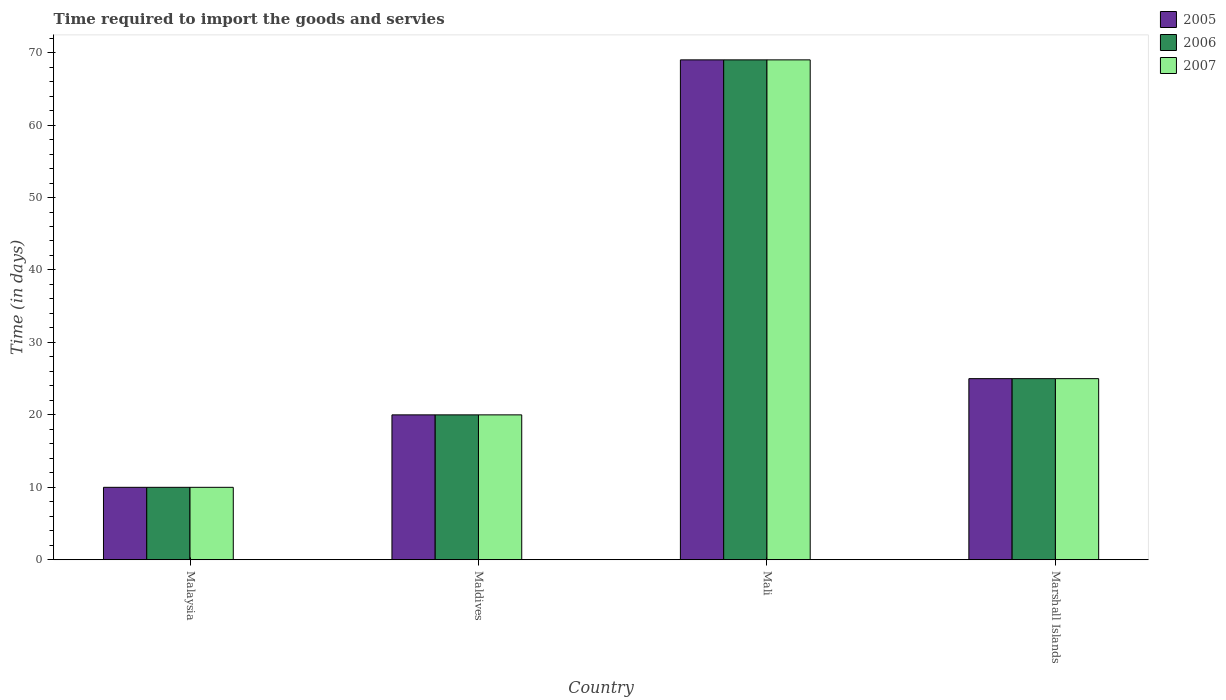How many different coloured bars are there?
Your answer should be very brief. 3. Are the number of bars on each tick of the X-axis equal?
Make the answer very short. Yes. How many bars are there on the 2nd tick from the right?
Keep it short and to the point. 3. What is the label of the 3rd group of bars from the left?
Your answer should be very brief. Mali. In how many cases, is the number of bars for a given country not equal to the number of legend labels?
Your answer should be very brief. 0. What is the number of days required to import the goods and services in 2005 in Malaysia?
Your response must be concise. 10. Across all countries, what is the maximum number of days required to import the goods and services in 2007?
Ensure brevity in your answer.  69. In which country was the number of days required to import the goods and services in 2006 maximum?
Make the answer very short. Mali. In which country was the number of days required to import the goods and services in 2006 minimum?
Provide a short and direct response. Malaysia. What is the total number of days required to import the goods and services in 2006 in the graph?
Provide a short and direct response. 124. What is the difference between the number of days required to import the goods and services in 2005 in Maldives and that in Mali?
Your response must be concise. -49. What is the difference between the number of days required to import the goods and services in 2007 in Mali and the number of days required to import the goods and services in 2006 in Maldives?
Offer a terse response. 49. What is the average number of days required to import the goods and services in 2007 per country?
Offer a terse response. 31. Is the sum of the number of days required to import the goods and services in 2005 in Malaysia and Maldives greater than the maximum number of days required to import the goods and services in 2007 across all countries?
Provide a succinct answer. No. What does the 3rd bar from the right in Malaysia represents?
Offer a terse response. 2005. Is it the case that in every country, the sum of the number of days required to import the goods and services in 2005 and number of days required to import the goods and services in 2007 is greater than the number of days required to import the goods and services in 2006?
Keep it short and to the point. Yes. Are all the bars in the graph horizontal?
Ensure brevity in your answer.  No. Does the graph contain grids?
Provide a succinct answer. No. How are the legend labels stacked?
Your answer should be very brief. Vertical. What is the title of the graph?
Provide a short and direct response. Time required to import the goods and servies. What is the label or title of the Y-axis?
Make the answer very short. Time (in days). What is the Time (in days) of 2005 in Maldives?
Keep it short and to the point. 20. What is the Time (in days) in 2006 in Maldives?
Your response must be concise. 20. What is the Time (in days) in 2007 in Maldives?
Your answer should be very brief. 20. What is the Time (in days) of 2007 in Mali?
Provide a succinct answer. 69. What is the Time (in days) of 2006 in Marshall Islands?
Provide a short and direct response. 25. What is the Time (in days) of 2007 in Marshall Islands?
Provide a succinct answer. 25. Across all countries, what is the maximum Time (in days) of 2007?
Your answer should be compact. 69. Across all countries, what is the minimum Time (in days) of 2005?
Provide a short and direct response. 10. Across all countries, what is the minimum Time (in days) of 2006?
Offer a terse response. 10. Across all countries, what is the minimum Time (in days) in 2007?
Your answer should be compact. 10. What is the total Time (in days) of 2005 in the graph?
Provide a short and direct response. 124. What is the total Time (in days) in 2006 in the graph?
Keep it short and to the point. 124. What is the total Time (in days) of 2007 in the graph?
Provide a short and direct response. 124. What is the difference between the Time (in days) in 2005 in Malaysia and that in Mali?
Your response must be concise. -59. What is the difference between the Time (in days) of 2006 in Malaysia and that in Mali?
Give a very brief answer. -59. What is the difference between the Time (in days) in 2007 in Malaysia and that in Mali?
Give a very brief answer. -59. What is the difference between the Time (in days) of 2006 in Malaysia and that in Marshall Islands?
Offer a very short reply. -15. What is the difference between the Time (in days) in 2005 in Maldives and that in Mali?
Your answer should be very brief. -49. What is the difference between the Time (in days) in 2006 in Maldives and that in Mali?
Ensure brevity in your answer.  -49. What is the difference between the Time (in days) in 2007 in Maldives and that in Mali?
Provide a succinct answer. -49. What is the difference between the Time (in days) in 2005 in Maldives and that in Marshall Islands?
Offer a very short reply. -5. What is the difference between the Time (in days) in 2006 in Maldives and that in Marshall Islands?
Offer a terse response. -5. What is the difference between the Time (in days) in 2007 in Mali and that in Marshall Islands?
Give a very brief answer. 44. What is the difference between the Time (in days) in 2005 in Malaysia and the Time (in days) in 2006 in Maldives?
Provide a succinct answer. -10. What is the difference between the Time (in days) in 2005 in Malaysia and the Time (in days) in 2007 in Maldives?
Offer a terse response. -10. What is the difference between the Time (in days) in 2005 in Malaysia and the Time (in days) in 2006 in Mali?
Offer a very short reply. -59. What is the difference between the Time (in days) of 2005 in Malaysia and the Time (in days) of 2007 in Mali?
Ensure brevity in your answer.  -59. What is the difference between the Time (in days) in 2006 in Malaysia and the Time (in days) in 2007 in Mali?
Keep it short and to the point. -59. What is the difference between the Time (in days) in 2005 in Malaysia and the Time (in days) in 2007 in Marshall Islands?
Provide a short and direct response. -15. What is the difference between the Time (in days) of 2006 in Malaysia and the Time (in days) of 2007 in Marshall Islands?
Your answer should be compact. -15. What is the difference between the Time (in days) in 2005 in Maldives and the Time (in days) in 2006 in Mali?
Make the answer very short. -49. What is the difference between the Time (in days) in 2005 in Maldives and the Time (in days) in 2007 in Mali?
Ensure brevity in your answer.  -49. What is the difference between the Time (in days) in 2006 in Maldives and the Time (in days) in 2007 in Mali?
Offer a very short reply. -49. What is the difference between the Time (in days) of 2005 in Maldives and the Time (in days) of 2006 in Marshall Islands?
Ensure brevity in your answer.  -5. What is the difference between the Time (in days) in 2006 in Maldives and the Time (in days) in 2007 in Marshall Islands?
Your answer should be very brief. -5. What is the difference between the Time (in days) in 2005 in Mali and the Time (in days) in 2006 in Marshall Islands?
Offer a very short reply. 44. What is the difference between the Time (in days) in 2006 in Mali and the Time (in days) in 2007 in Marshall Islands?
Provide a short and direct response. 44. What is the average Time (in days) of 2005 per country?
Make the answer very short. 31. What is the average Time (in days) in 2007 per country?
Your response must be concise. 31. What is the difference between the Time (in days) of 2005 and Time (in days) of 2006 in Malaysia?
Make the answer very short. 0. What is the difference between the Time (in days) of 2005 and Time (in days) of 2006 in Maldives?
Offer a very short reply. 0. What is the difference between the Time (in days) in 2005 and Time (in days) in 2006 in Mali?
Your answer should be compact. 0. What is the difference between the Time (in days) of 2006 and Time (in days) of 2007 in Marshall Islands?
Provide a short and direct response. 0. What is the ratio of the Time (in days) in 2006 in Malaysia to that in Maldives?
Ensure brevity in your answer.  0.5. What is the ratio of the Time (in days) of 2005 in Malaysia to that in Mali?
Your response must be concise. 0.14. What is the ratio of the Time (in days) in 2006 in Malaysia to that in Mali?
Your response must be concise. 0.14. What is the ratio of the Time (in days) of 2007 in Malaysia to that in Mali?
Make the answer very short. 0.14. What is the ratio of the Time (in days) of 2005 in Maldives to that in Mali?
Keep it short and to the point. 0.29. What is the ratio of the Time (in days) in 2006 in Maldives to that in Mali?
Make the answer very short. 0.29. What is the ratio of the Time (in days) in 2007 in Maldives to that in Mali?
Your response must be concise. 0.29. What is the ratio of the Time (in days) of 2007 in Maldives to that in Marshall Islands?
Your response must be concise. 0.8. What is the ratio of the Time (in days) in 2005 in Mali to that in Marshall Islands?
Your answer should be compact. 2.76. What is the ratio of the Time (in days) in 2006 in Mali to that in Marshall Islands?
Provide a short and direct response. 2.76. What is the ratio of the Time (in days) in 2007 in Mali to that in Marshall Islands?
Ensure brevity in your answer.  2.76. What is the difference between the highest and the second highest Time (in days) in 2005?
Provide a succinct answer. 44. What is the difference between the highest and the lowest Time (in days) in 2005?
Ensure brevity in your answer.  59. What is the difference between the highest and the lowest Time (in days) in 2006?
Provide a short and direct response. 59. What is the difference between the highest and the lowest Time (in days) of 2007?
Provide a short and direct response. 59. 